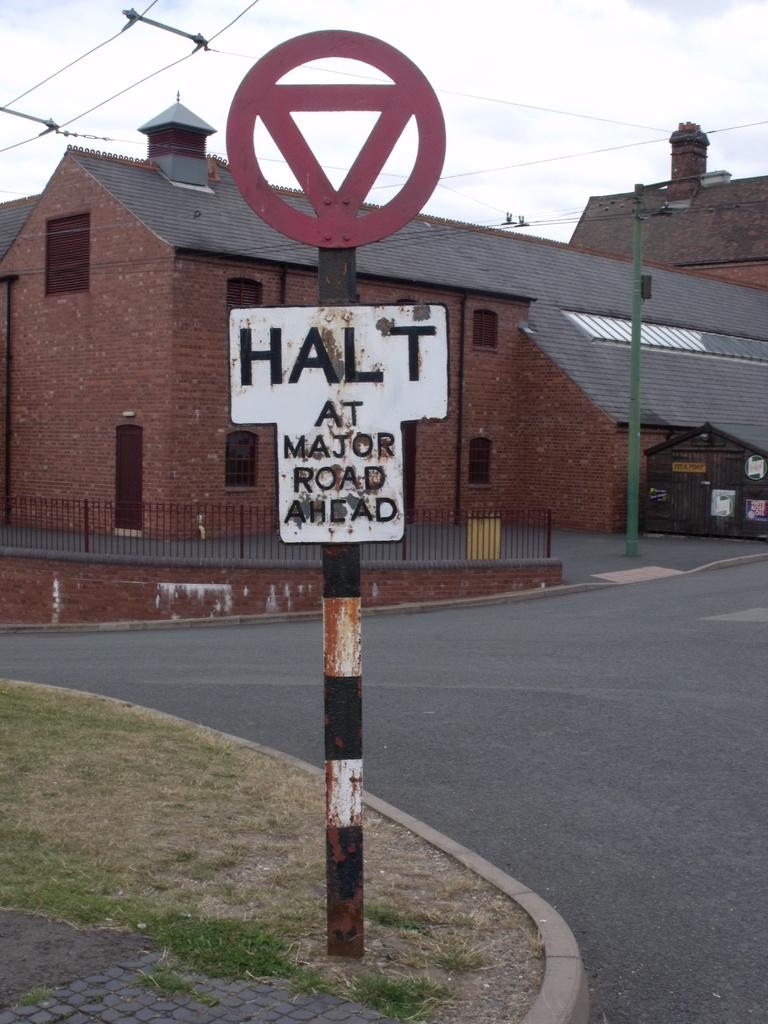<image>
Describe the image concisely. A white and black sign states Halt at major road ahead. 